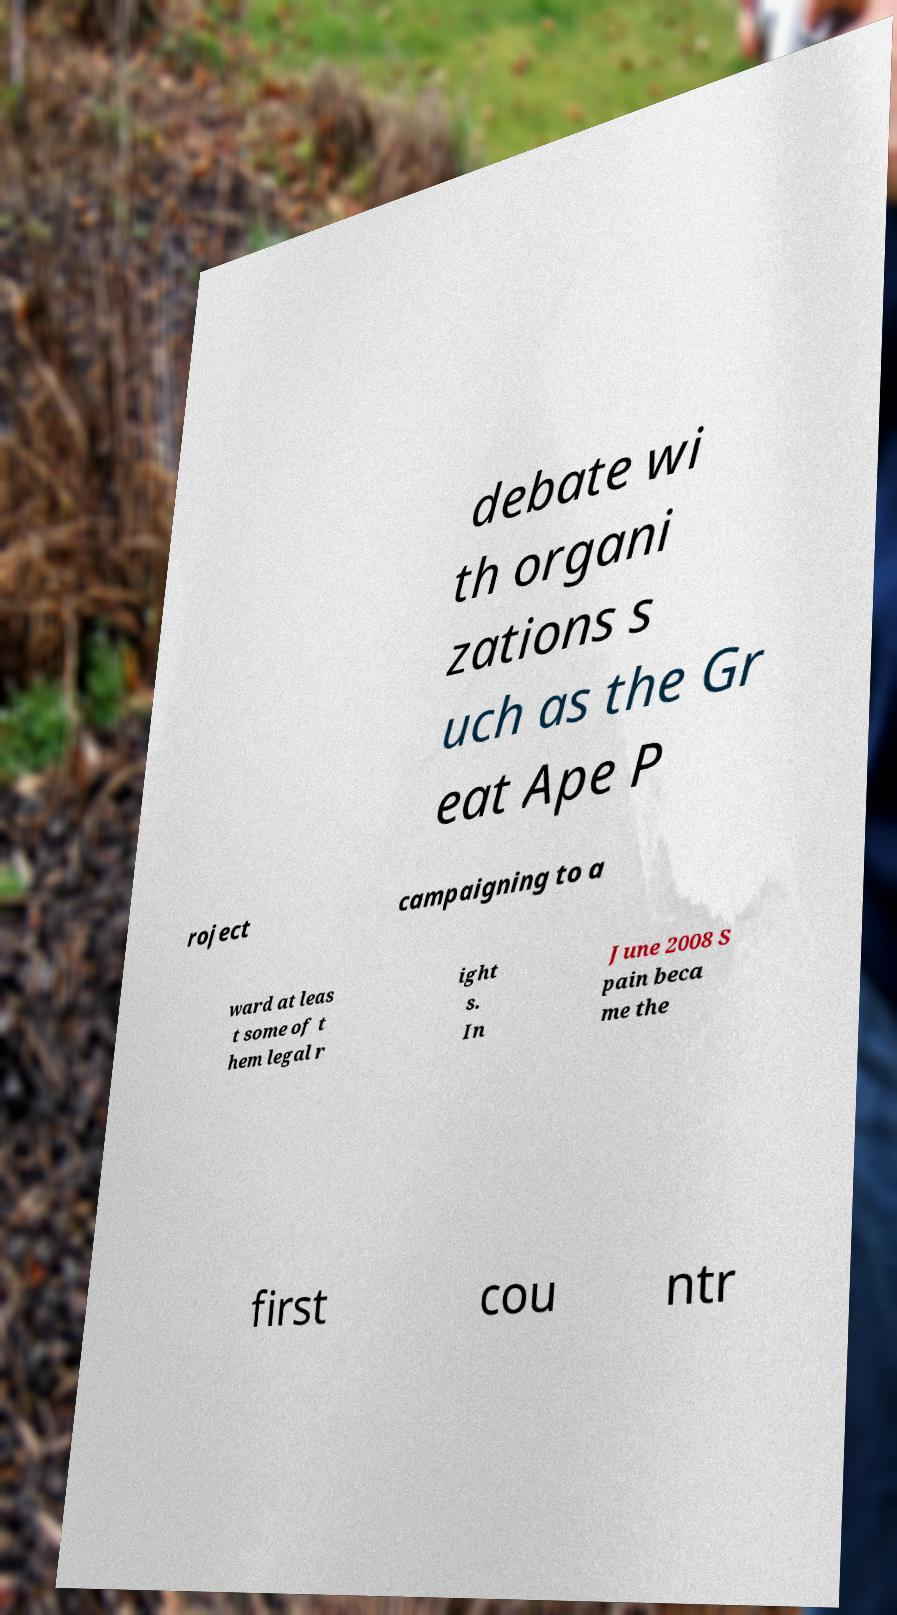There's text embedded in this image that I need extracted. Can you transcribe it verbatim? debate wi th organi zations s uch as the Gr eat Ape P roject campaigning to a ward at leas t some of t hem legal r ight s. In June 2008 S pain beca me the first cou ntr 